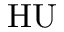Convert formula to latex. <formula><loc_0><loc_0><loc_500><loc_500>H U</formula> 